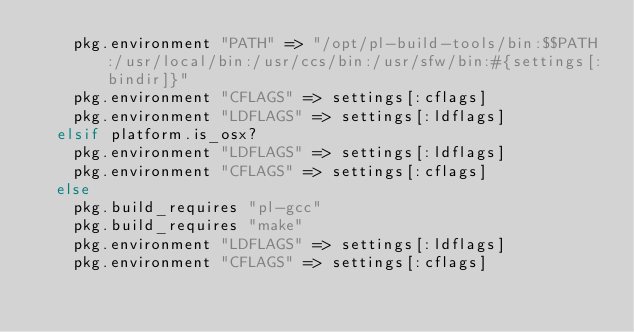Convert code to text. <code><loc_0><loc_0><loc_500><loc_500><_Ruby_>    pkg.environment "PATH" => "/opt/pl-build-tools/bin:$$PATH:/usr/local/bin:/usr/ccs/bin:/usr/sfw/bin:#{settings[:bindir]}"
    pkg.environment "CFLAGS" => settings[:cflags]
    pkg.environment "LDFLAGS" => settings[:ldflags]
  elsif platform.is_osx?
    pkg.environment "LDFLAGS" => settings[:ldflags]
    pkg.environment "CFLAGS" => settings[:cflags]
  else
    pkg.build_requires "pl-gcc"
    pkg.build_requires "make"
    pkg.environment "LDFLAGS" => settings[:ldflags]
    pkg.environment "CFLAGS" => settings[:cflags]</code> 